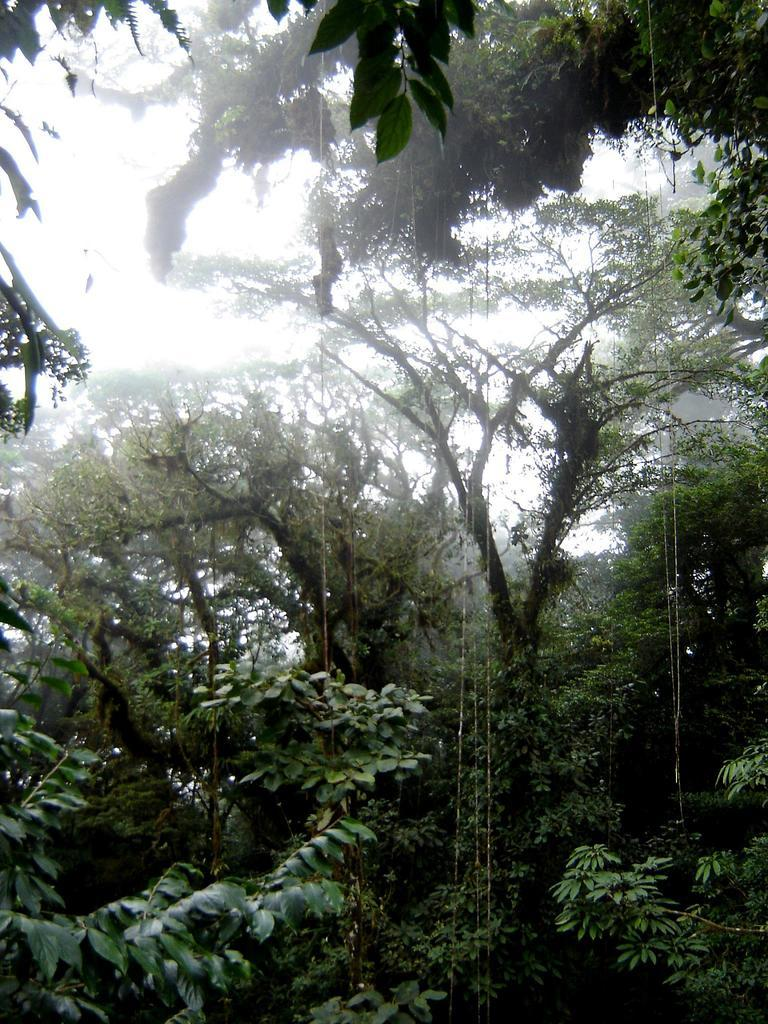What type of vegetation can be seen in the image? There are trees visible in the image. What part of the natural environment is visible in the image? The sky is visible in the background of the image. What type of apparel is hanging on the shelf in the image? There is no shelf or apparel present in the image. What type of beast can be seen roaming in the image? There is no beast present in the image. 